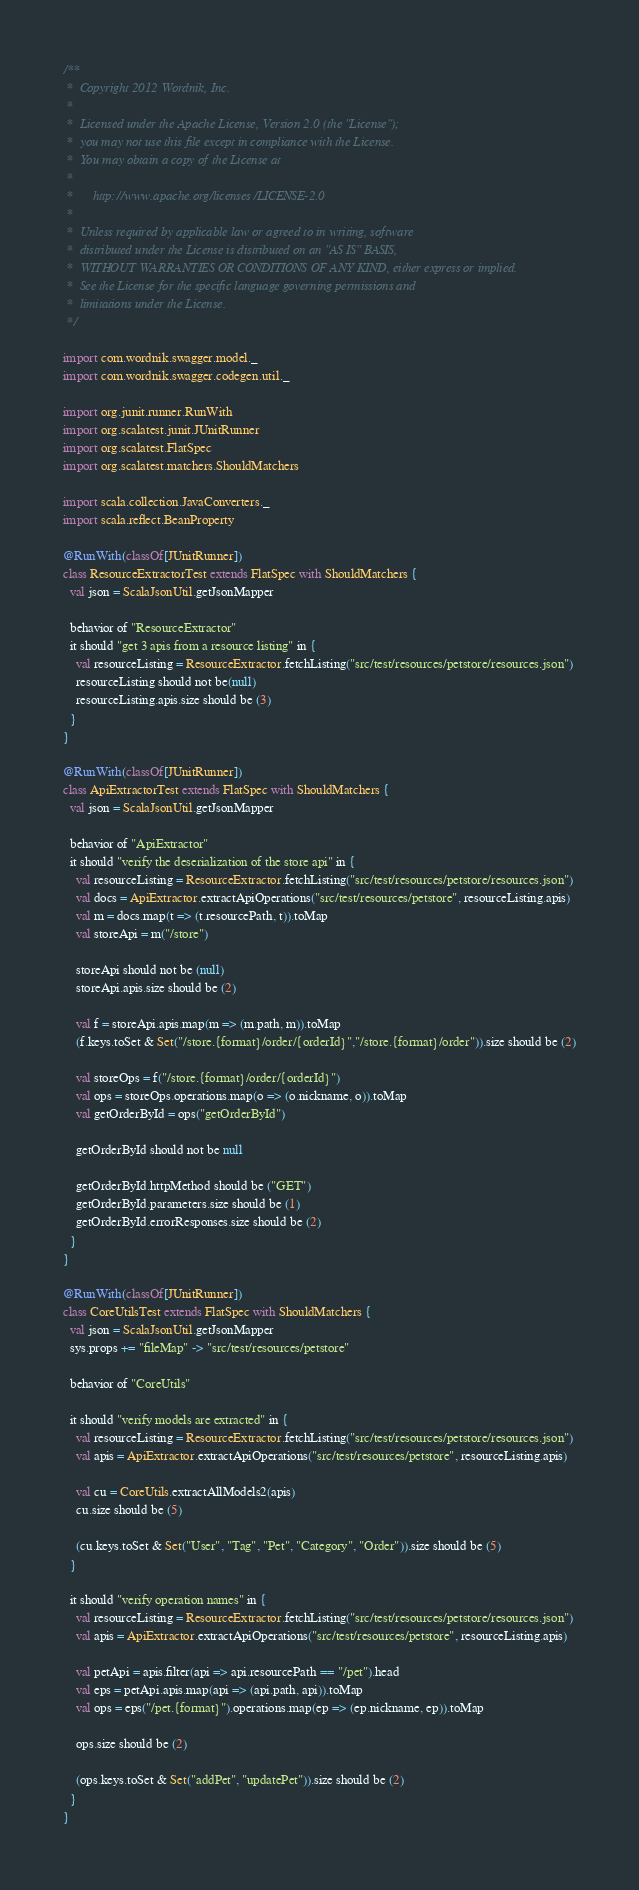<code> <loc_0><loc_0><loc_500><loc_500><_Scala_>/**
 *  Copyright 2012 Wordnik, Inc.
 *
 *  Licensed under the Apache License, Version 2.0 (the "License");
 *  you may not use this file except in compliance with the License.
 *  You may obtain a copy of the License at
 *
 *      http://www.apache.org/licenses/LICENSE-2.0
 *
 *  Unless required by applicable law or agreed to in writing, software
 *  distributed under the License is distributed on an "AS IS" BASIS,
 *  WITHOUT WARRANTIES OR CONDITIONS OF ANY KIND, either express or implied.
 *  See the License for the specific language governing permissions and
 *  limitations under the License.
 */

import com.wordnik.swagger.model._
import com.wordnik.swagger.codegen.util._

import org.junit.runner.RunWith
import org.scalatest.junit.JUnitRunner
import org.scalatest.FlatSpec
import org.scalatest.matchers.ShouldMatchers

import scala.collection.JavaConverters._
import scala.reflect.BeanProperty

@RunWith(classOf[JUnitRunner])
class ResourceExtractorTest extends FlatSpec with ShouldMatchers {
  val json = ScalaJsonUtil.getJsonMapper

  behavior of "ResourceExtractor"
  it should "get 3 apis from a resource listing" in {
    val resourceListing = ResourceExtractor.fetchListing("src/test/resources/petstore/resources.json")
    resourceListing should not be(null)
    resourceListing.apis.size should be (3)
  }
}

@RunWith(classOf[JUnitRunner])
class ApiExtractorTest extends FlatSpec with ShouldMatchers {
  val json = ScalaJsonUtil.getJsonMapper

  behavior of "ApiExtractor"
  it should "verify the deserialization of the store api" in {
    val resourceListing = ResourceExtractor.fetchListing("src/test/resources/petstore/resources.json")
    val docs = ApiExtractor.extractApiOperations("src/test/resources/petstore", resourceListing.apis)
    val m = docs.map(t => (t.resourcePath, t)).toMap
    val storeApi = m("/store")

    storeApi should not be (null)
    storeApi.apis.size should be (2)

    val f = storeApi.apis.map(m => (m.path, m)).toMap
    (f.keys.toSet & Set("/store.{format}/order/{orderId}","/store.{format}/order")).size should be (2)

    val storeOps = f("/store.{format}/order/{orderId}")
    val ops = storeOps.operations.map(o => (o.nickname, o)).toMap
    val getOrderById = ops("getOrderById")

    getOrderById should not be null

    getOrderById.httpMethod should be ("GET")
    getOrderById.parameters.size should be (1)
    getOrderById.errorResponses.size should be (2)
  }
}

@RunWith(classOf[JUnitRunner])
class CoreUtilsTest extends FlatSpec with ShouldMatchers {
  val json = ScalaJsonUtil.getJsonMapper
  sys.props += "fileMap" -> "src/test/resources/petstore"

  behavior of "CoreUtils"

  it should "verify models are extracted" in {
    val resourceListing = ResourceExtractor.fetchListing("src/test/resources/petstore/resources.json")
    val apis = ApiExtractor.extractApiOperations("src/test/resources/petstore", resourceListing.apis)

    val cu = CoreUtils.extractAllModels2(apis)
    cu.size should be (5)

    (cu.keys.toSet & Set("User", "Tag", "Pet", "Category", "Order")).size should be (5)
  }

  it should "verify operation names" in {
    val resourceListing = ResourceExtractor.fetchListing("src/test/resources/petstore/resources.json")
    val apis = ApiExtractor.extractApiOperations("src/test/resources/petstore", resourceListing.apis)

    val petApi = apis.filter(api => api.resourcePath == "/pet").head
    val eps = petApi.apis.map(api => (api.path, api)).toMap
    val ops = eps("/pet.{format}").operations.map(ep => (ep.nickname, ep)).toMap

    ops.size should be (2)

    (ops.keys.toSet & Set("addPet", "updatePet")).size should be (2)
  }
}</code> 